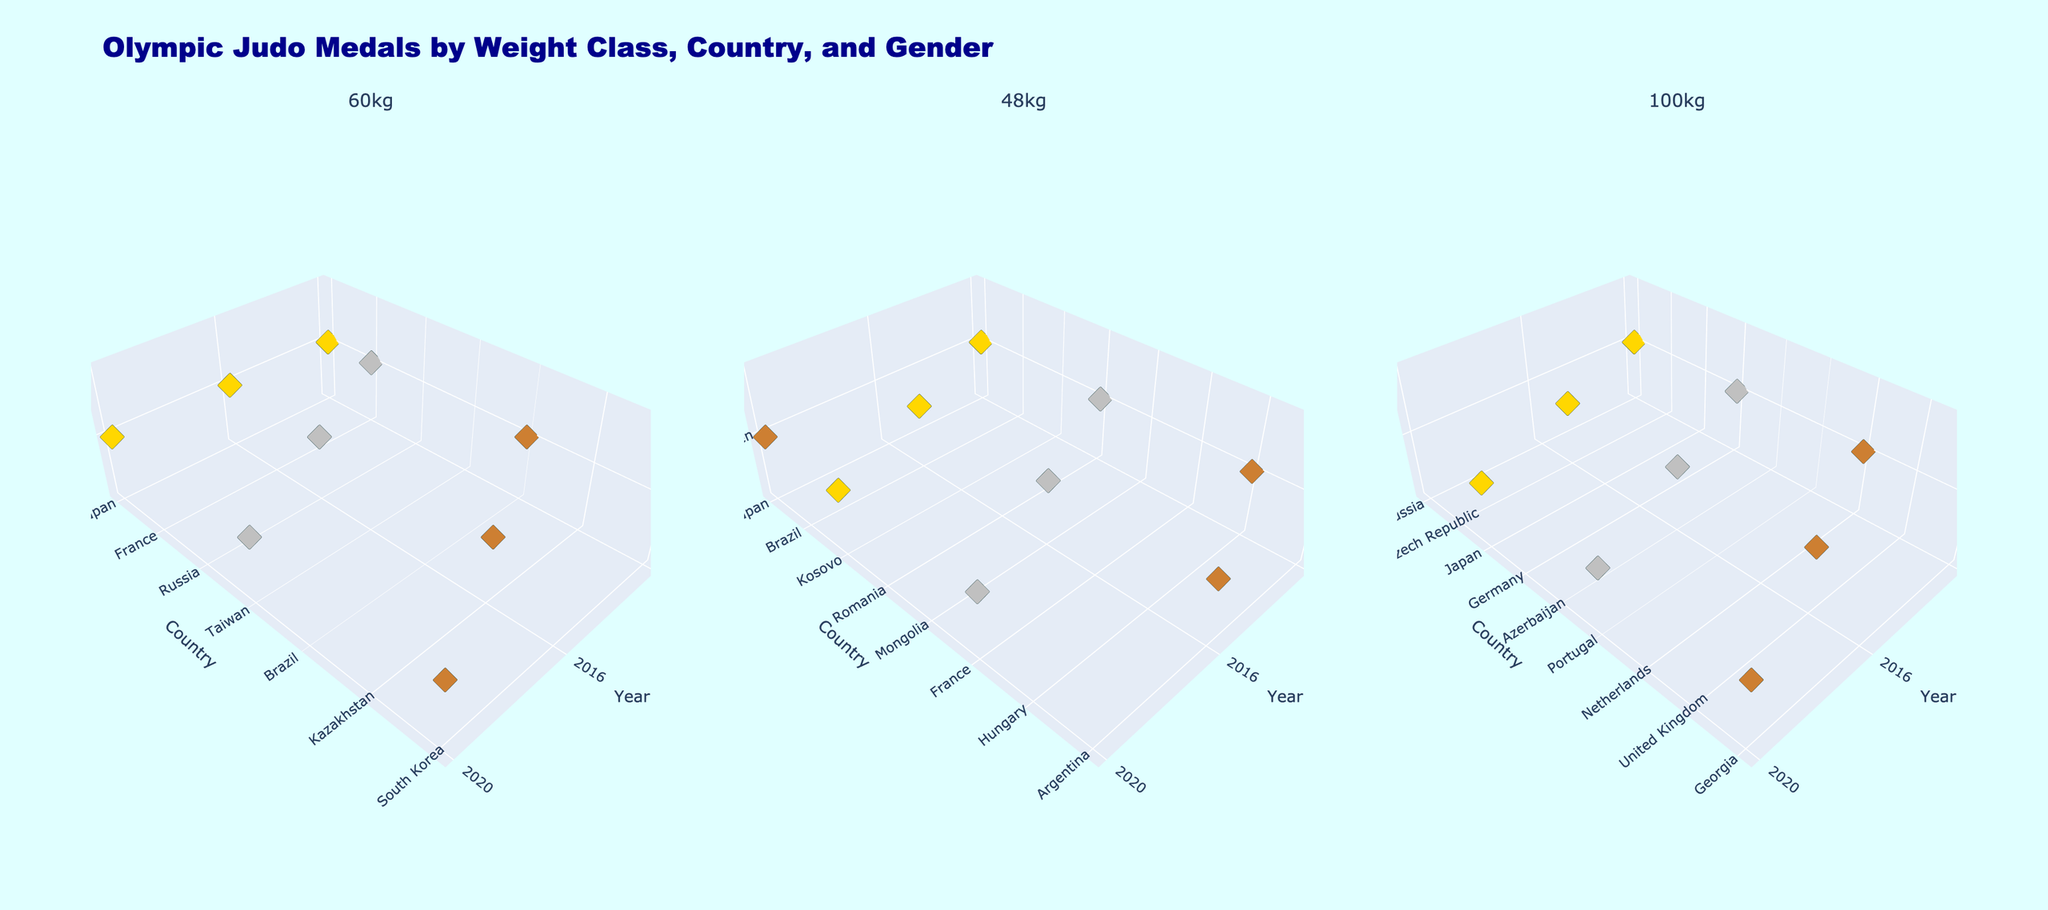Which country consistently won the gold medal in the Men's 60kg weight class from 2012 to 2020? In the Men's 60kg weight class subplot, identify the country with gold markers in the years 2012, 2016, and 2020.
Answer: Japan How many countries earned a silver medal in the Women's 48kg weight class across the three Olympic cycles displayed? Sum the number of distinct countries with silver markers in the Women's 48kg weight class subplot.
Answer: Three Which country won both a gold and a bronze medal in the Men's 100kg weight class in 2020? In the Men's 100kg weight class subplot, look for the country with both gold and bronze markers in the year 2020.
Answer: Japan Did any country win medals in both the Men's 60kg and Women's 48kg weight classes in 2012? Check if there are common countries with any type of medal markers in both Men's 60kg and Women's 48kg weight class subplots for 2012.
Answer: Japan How many medals in total did Japan win in the displayed weight classes from 2012 to 2020? Add up all the Japan markers in Men's 60kg, Women's 48kg, and Men's 100kg weight class subplots across all years.
Answer: Six Compare the number of gold medals won by countries in the Men's 60kg and Men's 100kg weight classes from 2012 to 2020. Which weight class had more gold medalists? Count the gold markers in the Men's 60kg and Men's 100kg weight class subplots and compare the totals.
Answer: Men's 60kg Which country won a silver medal in the Men's 60kg weight class in 2016? Look for the silver marker in the Men's 60kg weight class subplot for the year 2016.
Answer: Russia 